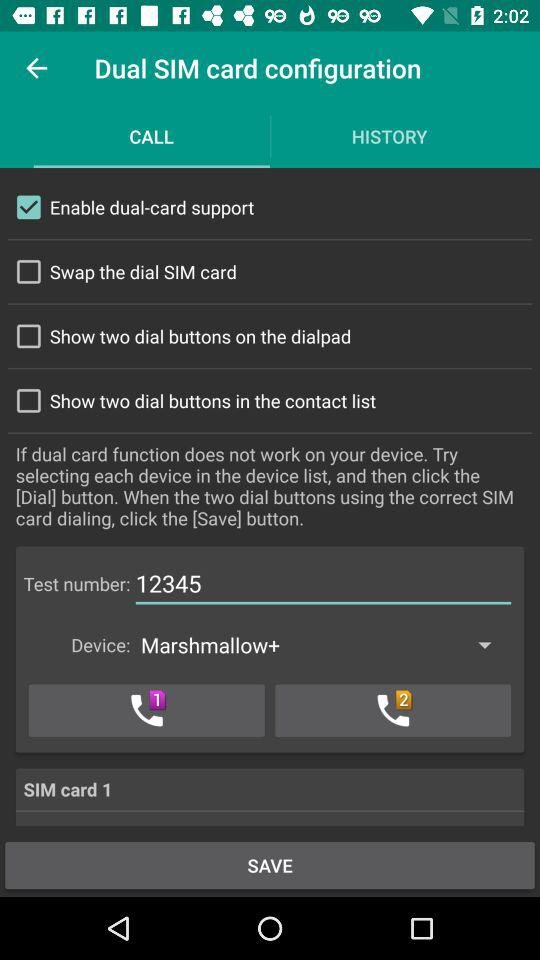Which tab is selected right now? The selected tab is "CALL". 